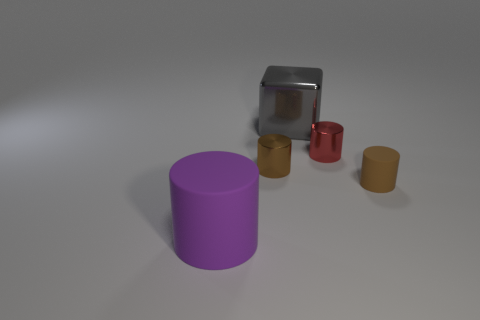What number of objects are big rubber objects that are in front of the big gray shiny cube or objects that are right of the big rubber cylinder? There are two large rubber items in view. Firstly, directly in front of the large gray cube, there is one large red rubber object. Secondly, to the right of the large purple rubber cylinder, we can see another large rubber object, which is brown. Therefore, the total number of big rubber objects that fulfill the conditions of being either in front of the big gray cube or to the right of the purple cylinder is two. 